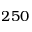Convert formula to latex. <formula><loc_0><loc_0><loc_500><loc_500>2 5 0</formula> 